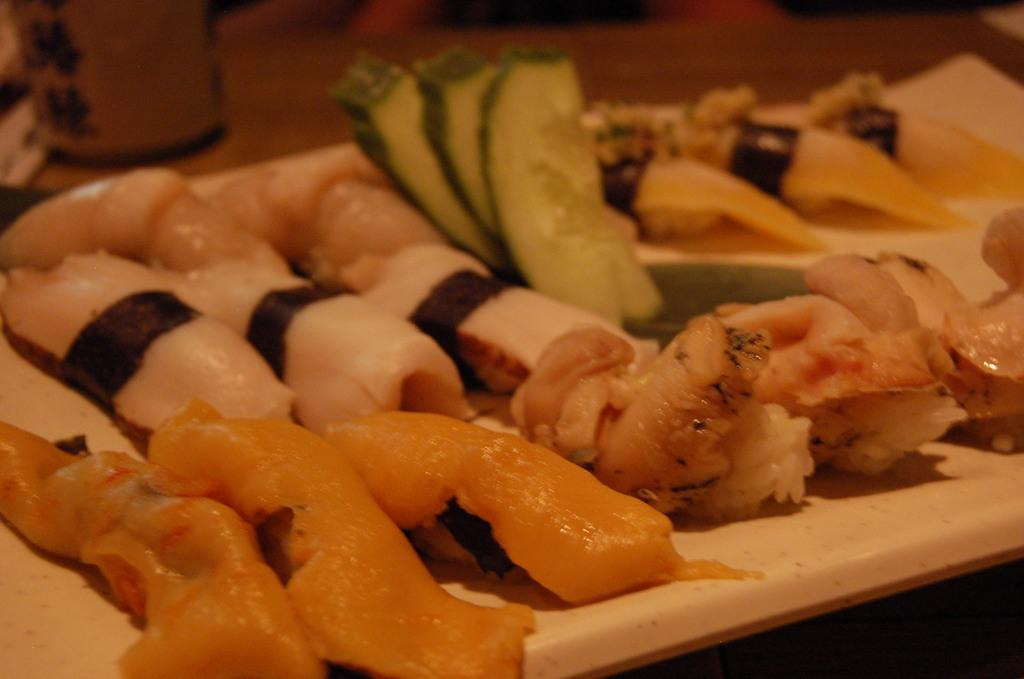What is the main object in the image? There is a white colored board in the image. What is placed on the board? There are food items on the board. Can you describe the colors of the food items? The food items have various colors: cream, brown, white, black, and green. How would you describe the background of the image? The background of the image is blurry. What type of government is depicted in the image? There is no depiction of a government in the image; it features a white colored board with food items on it. Can you see any flowers in the image? There are no flowers present in the image. 